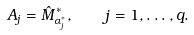<formula> <loc_0><loc_0><loc_500><loc_500>A _ { j } = \hat { M } _ { \alpha _ { j } ^ { * } } ^ { * } , \quad j = 1 , \dots , q .</formula> 